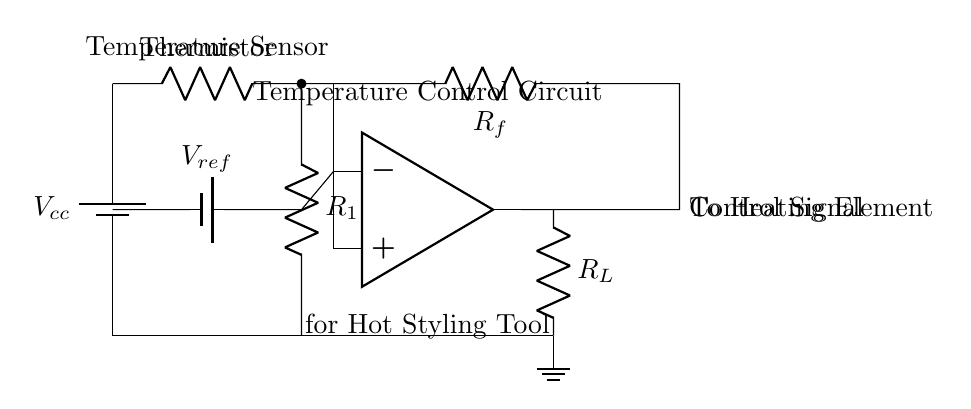What is the function of the thermistor? The thermistor serves as a temperature sensor, changing its resistance based on the temperature, thus allowing the circuit to monitor hot styling tool temperatures.
Answer: Temperature sensor What is connected to the op-amp's non-inverting input? The non-inverting input of the op-amp is connected to the thermistor voltage divider output which is influenced by the thermistor's resistance.
Answer: Thermistor output What is the purpose of the reference voltage? The reference voltage sets the threshold for the op-amp, determining the target temperature for the hot styling tool by comparing it with the input from the thermistor.
Answer: Temperature threshold How many resistors are present in this circuit? There are three resistors: the thermistor, a voltage divider resistor labeled R1, and a feedback resistor labeled Rf.
Answer: Three What happens at the output of the op-amp? The output of the op-amp produces a control signal that adjusts the heating element based on the temperature reading from the thermistor.
Answer: Control signal What does R_L represent in this circuit? R_L represents a load resistor and typically signifies the heating element that requires control for temperature management in the styling tool.
Answer: Heating element What is the supply voltage labeled as? The supply voltage in the circuit is labeled as Vcc, which powers the circuit components including the op-amp and thermistor.
Answer: Vcc 